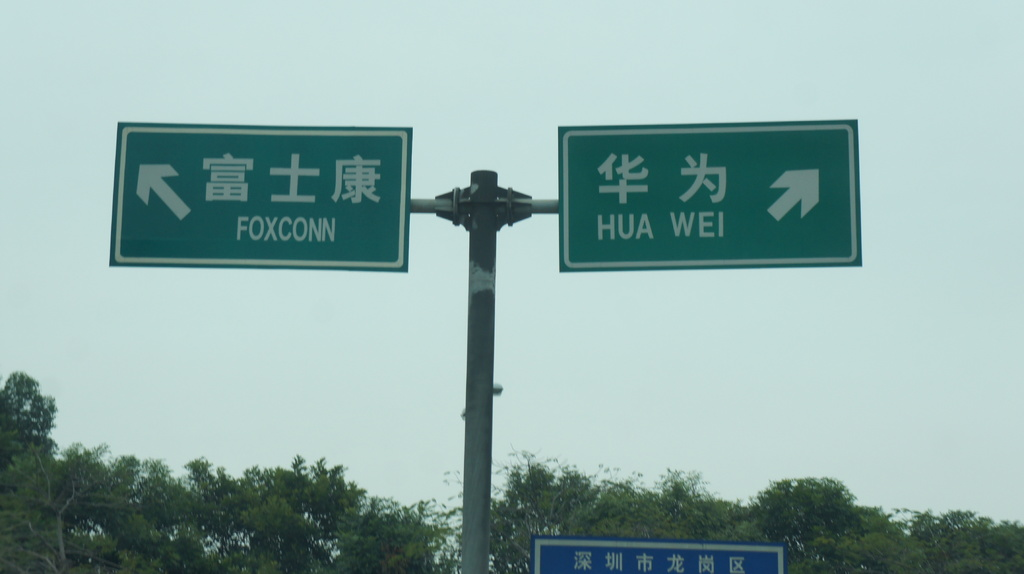What could be the significance of these two companies being located close to each other? The proximity of Foxconn and Huawei may suggest a high-tech industrial area specialized in electronics manufacturing and R&D, potentially fostering collaboration or competition between these leading tech companies. Does this region have any economic benefits from hosting these companies? Absolutely, regions hosting such tech giants often benefit from job creation, technological advancements, and increased global business opportunities, contributing to local economic growth and development. 